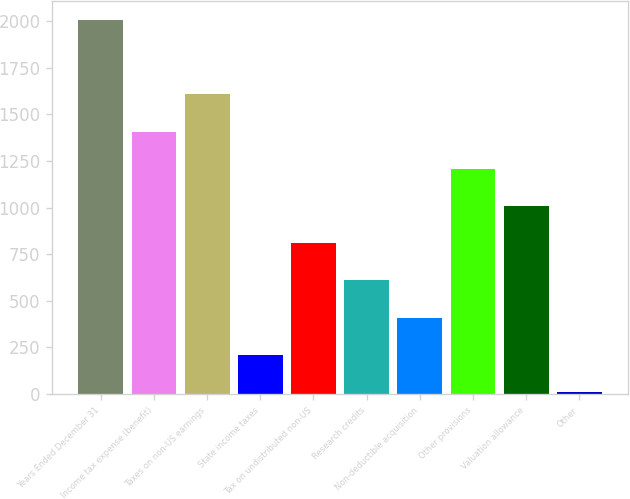Convert chart to OTSL. <chart><loc_0><loc_0><loc_500><loc_500><bar_chart><fcel>Years Ended December 31<fcel>Income tax expense (benefit)<fcel>Taxes on non-US earnings<fcel>State income taxes<fcel>Tax on undistributed non-US<fcel>Research credits<fcel>Non-deductible acquisition<fcel>Other provisions<fcel>Valuation allowance<fcel>Other<nl><fcel>2007<fcel>1408.2<fcel>1607.8<fcel>210.6<fcel>809.4<fcel>609.8<fcel>410.2<fcel>1208.6<fcel>1009<fcel>11<nl></chart> 